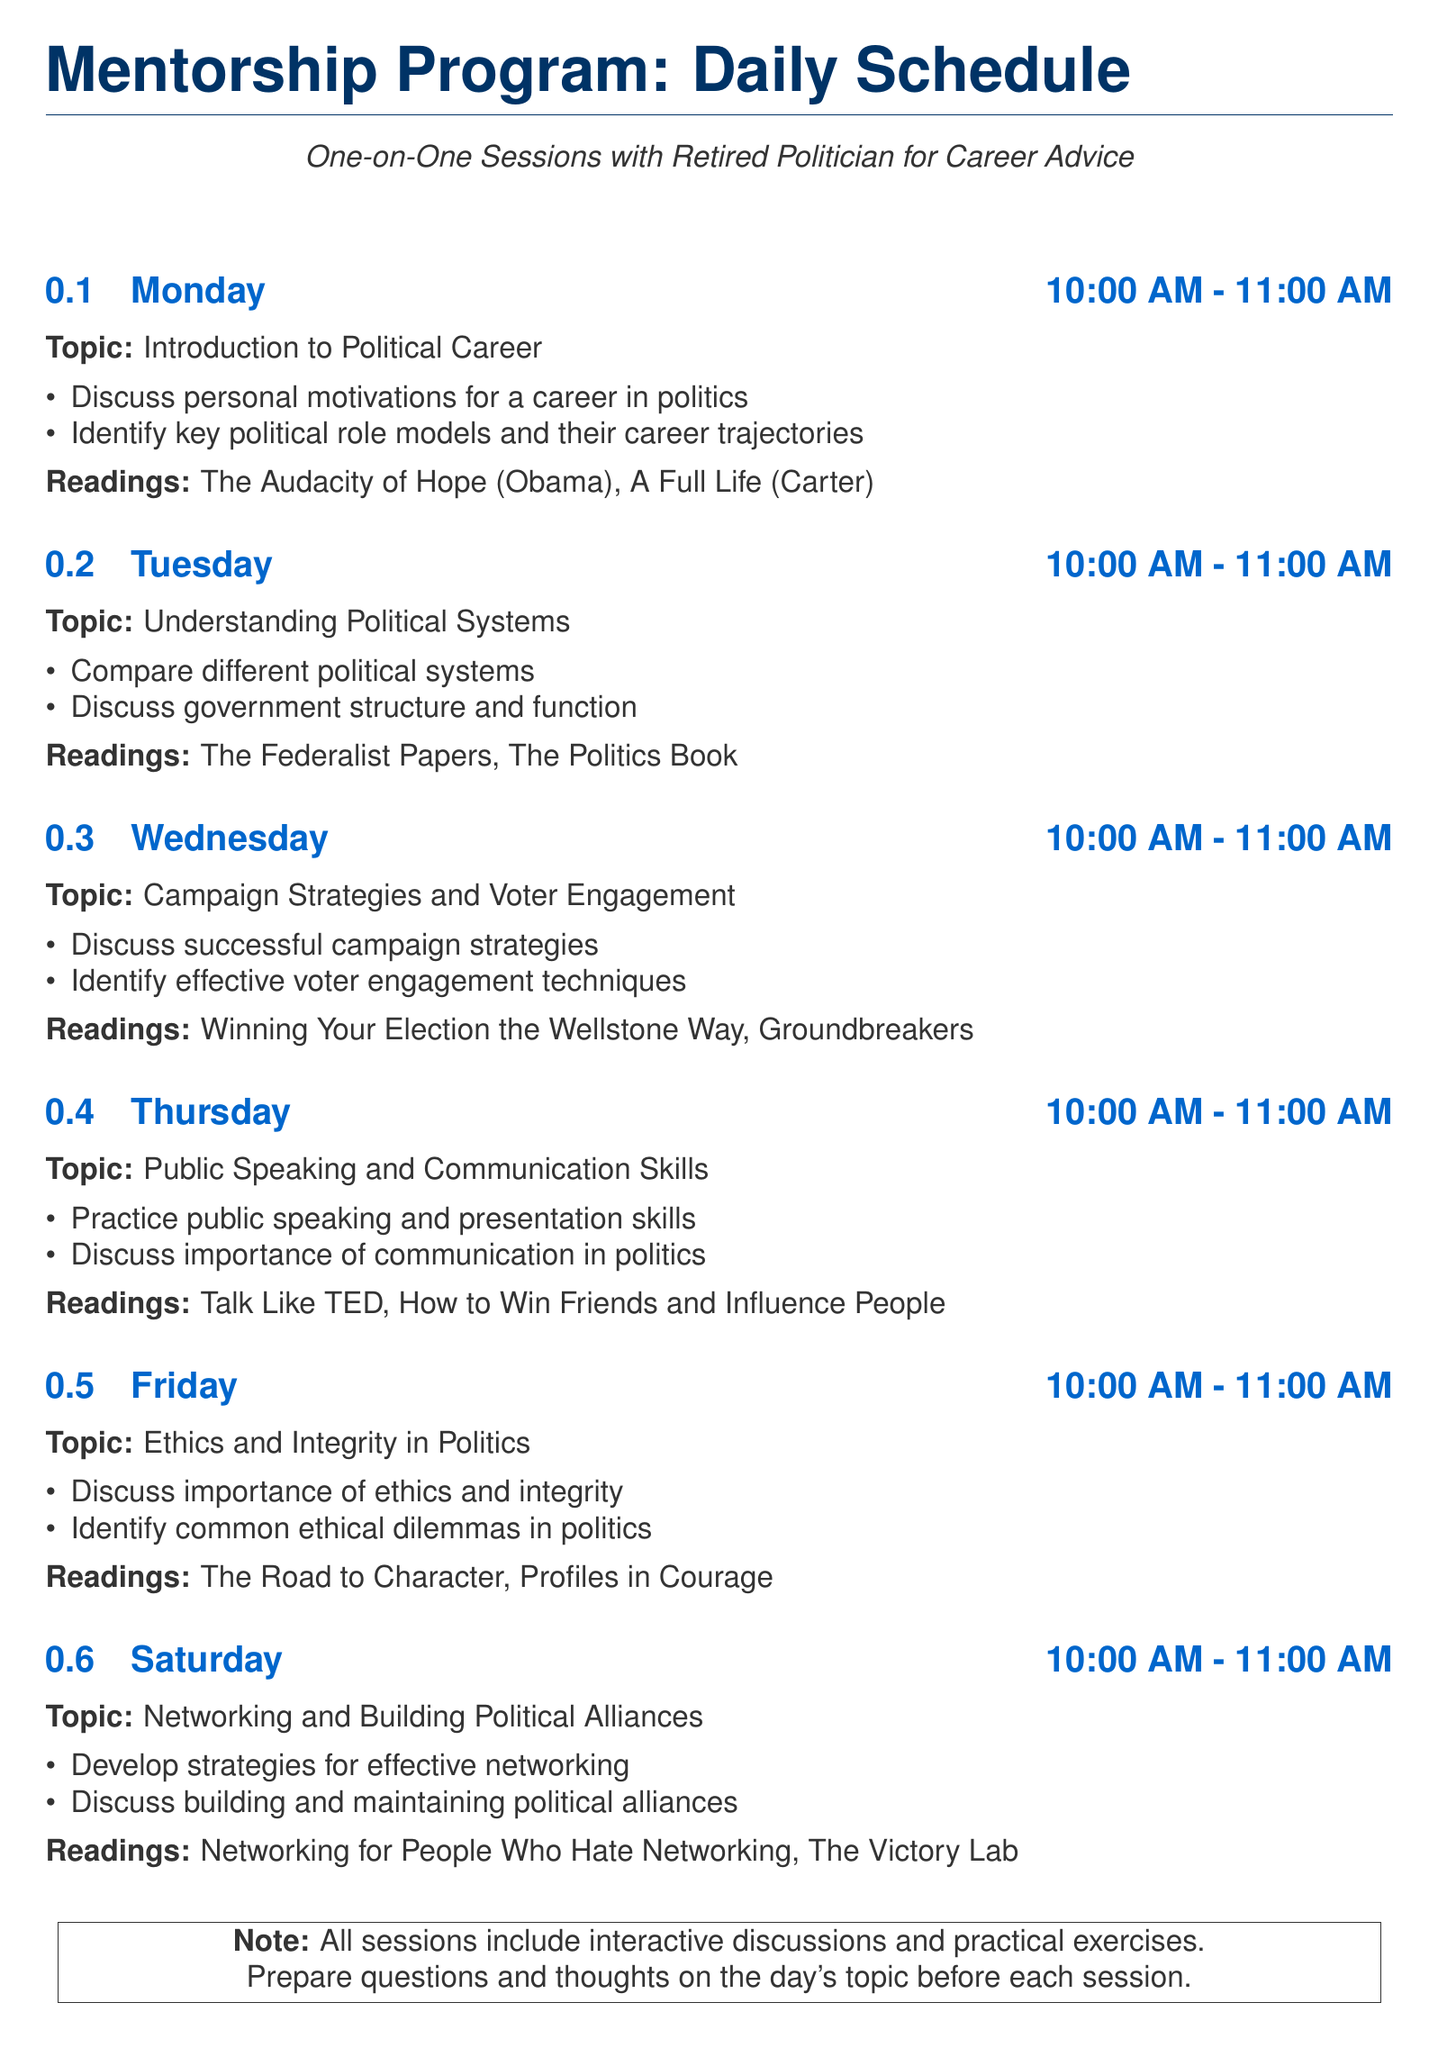What is the first topic discussed on Monday? The first topic on Monday is the introduction to a political career, as stated in the schedule.
Answer: Introduction to Political Career What time does the Wednesday session start? The session on Wednesday starts at 10:00 AM, which is indicated in the schedule for that day.
Answer: 10:00 AM What book is recommended for reading on Tuesday? The reading for Tuesday includes "The Federalist Papers," as shown in the reading section for that day.
Answer: The Federalist Papers How many overarching topics are discussed throughout the week? By counting each day's topic listed in the schedule, there are six topics throughout the week.
Answer: Six Which day's session focuses on ethics? The session on ethics and integrity takes place on Friday, as specified in the document.
Answer: Friday 